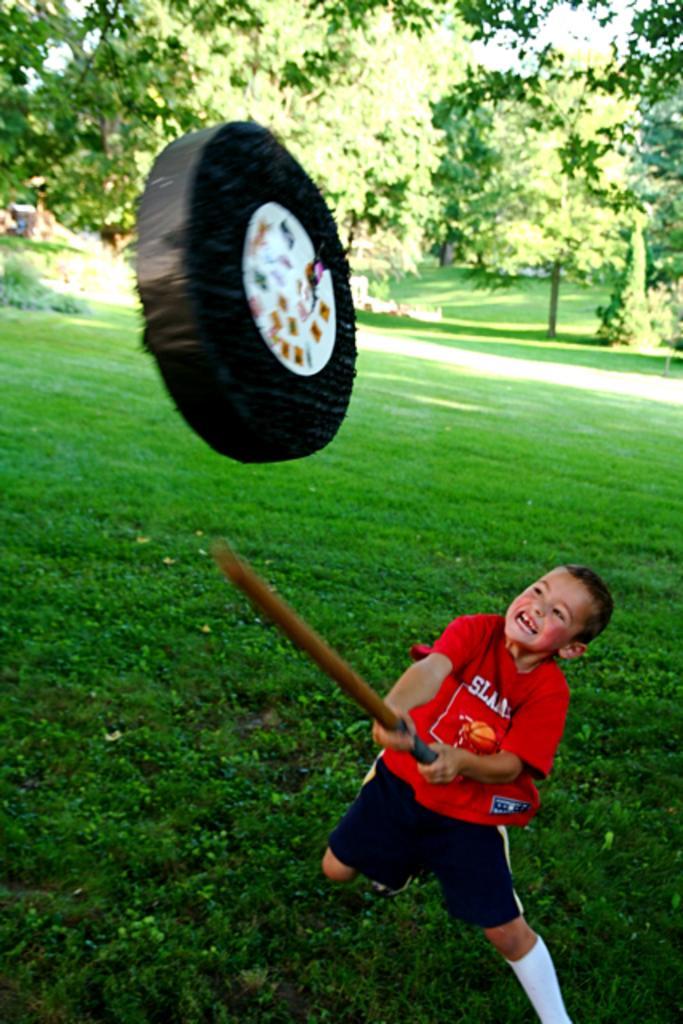Could you give a brief overview of what you see in this image? Here in this picture we can see a child present on the ground, which is fully covered with grass over there and trying to hit the wheel present in front of him with the help of a stick present in his hand and in the far we can see plants and trees present all over there. 